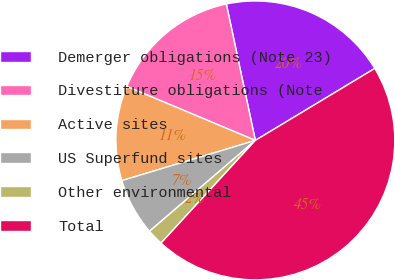Convert chart. <chart><loc_0><loc_0><loc_500><loc_500><pie_chart><fcel>Demerger obligations (Note 23)<fcel>Divestiture obligations (Note<fcel>Active sites<fcel>US Superfund sites<fcel>Other environmental<fcel>Total<nl><fcel>19.7%<fcel>15.34%<fcel>10.98%<fcel>6.63%<fcel>1.89%<fcel>45.45%<nl></chart> 